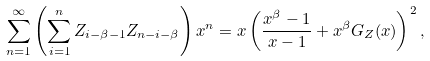<formula> <loc_0><loc_0><loc_500><loc_500>\sum _ { n = 1 } ^ { \infty } \left ( \sum _ { i = 1 } ^ { n } Z _ { i - \beta - 1 } Z _ { n - i - \beta } \right ) x ^ { n } = x \left ( \frac { x ^ { \beta } - 1 } { x - 1 } + x ^ { \beta } G _ { Z } ( x ) \right ) ^ { 2 } ,</formula> 